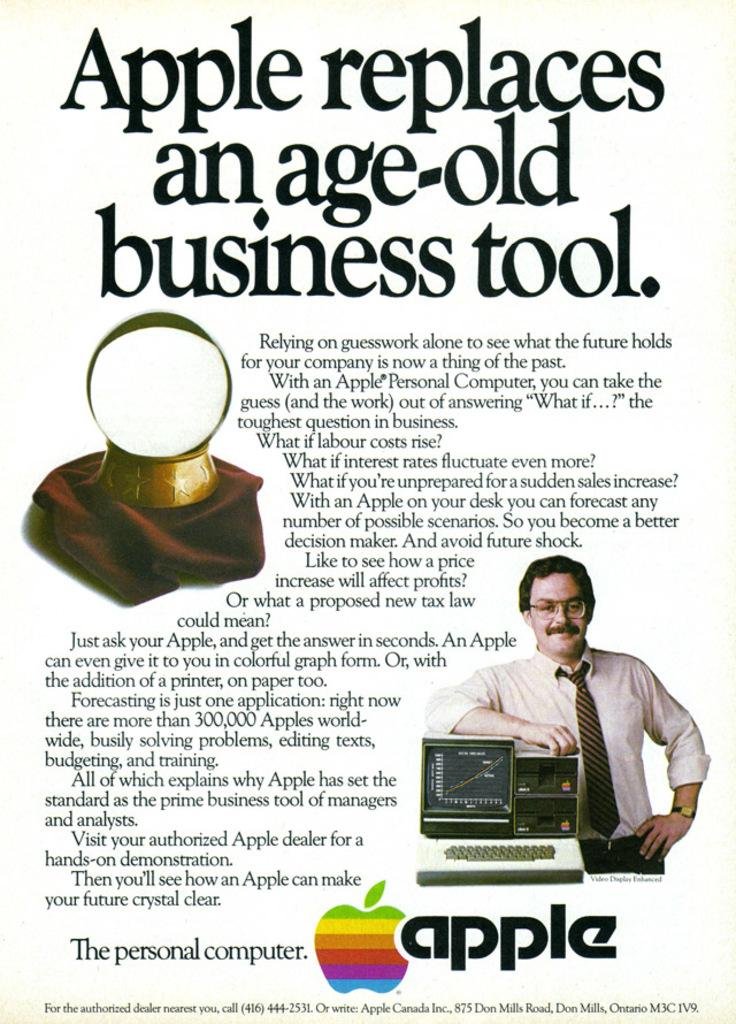<image>
Share a concise interpretation of the image provided. An old advertisement for an Apple personal computer. 